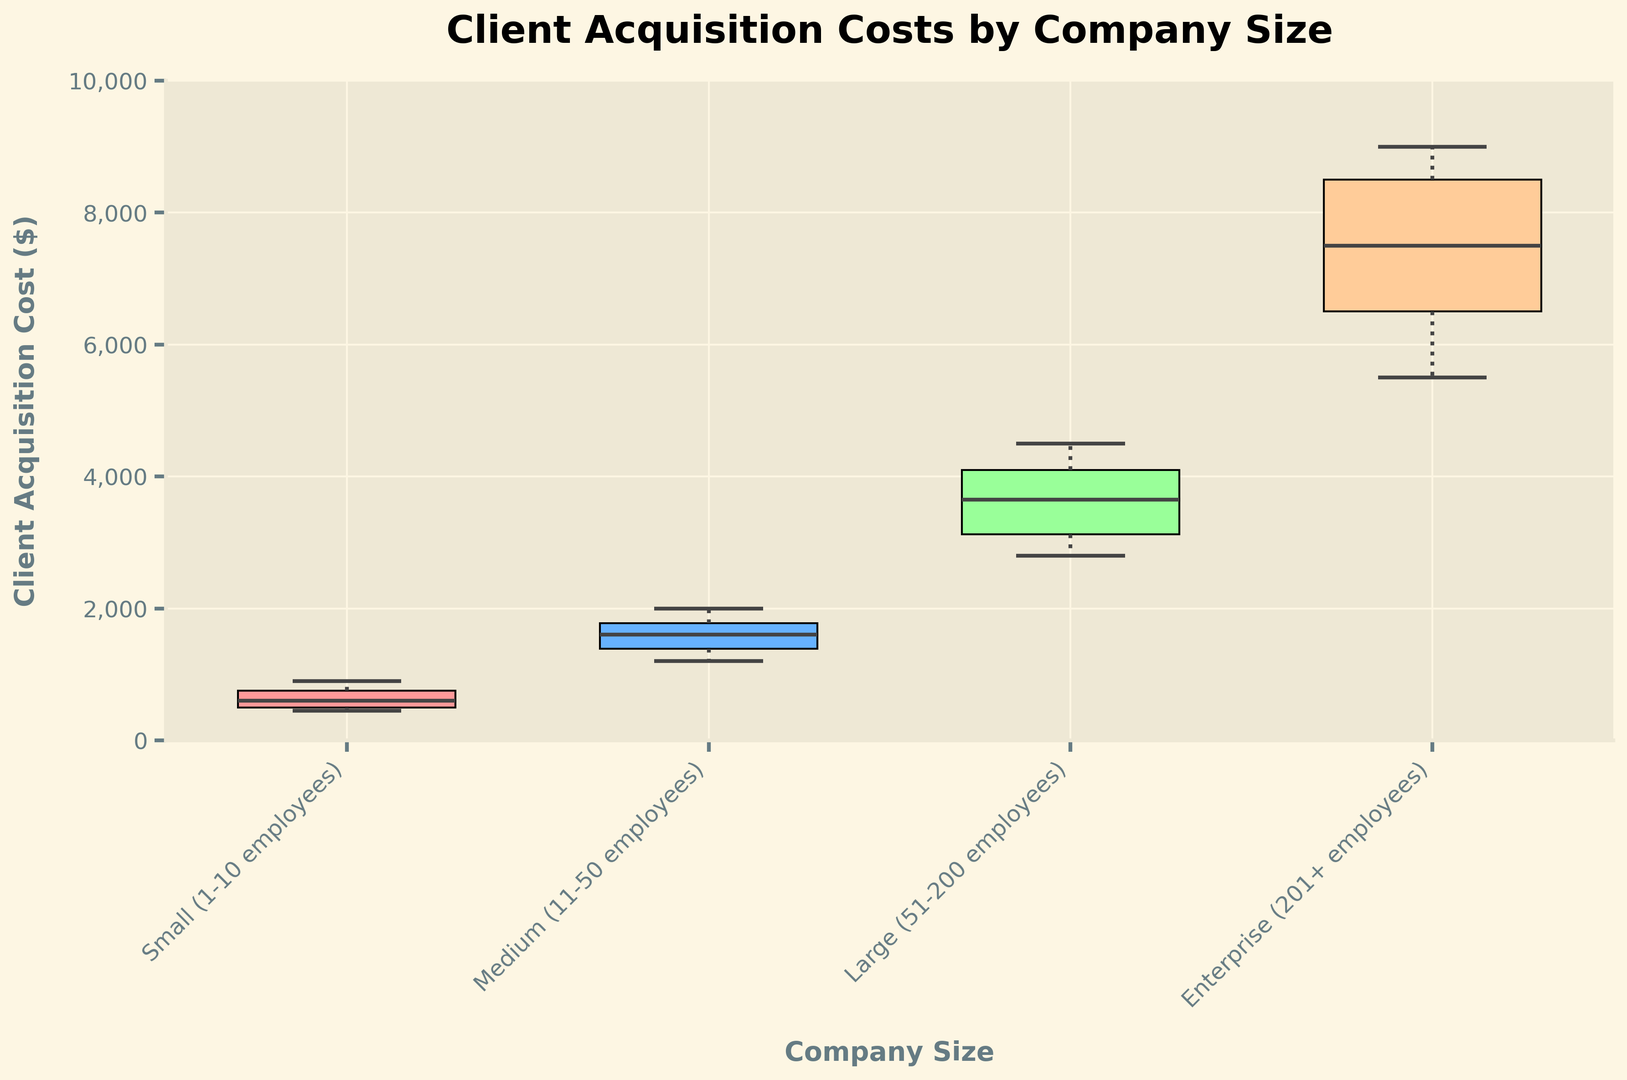What is the median Client Acquisition Cost for Small companies? To find the median, look at the middle value of the sorted data points for Small companies. The sorted data points are [450, 500, 600, 750, 900]. The median value is the middle one, which is 600.
Answer: 600 What is the range of Client Acquisition Costs for Medium companies? The range is calculated by subtracting the smallest value from the largest value in the data points for Medium companies. The costs are [1200, 1350, 1500, 1700, 1800, 2000], so the range is 2000 - 1200.
Answer: 800 Which company size category has the highest upper whisker in the box plot? The upper whisker represents the maximum data value excluding outliers. In the figure, the Enterprise company size has the highest upper whisker.
Answer: Enterprise For Large companies, what is the difference between the top and bottom quartile (interquartile range)? The interquartile range (IQR) is the difference between the third quartile (75th percentile) and the first quartile (25th percentile). For Large companies, the IQR is the distance between the top and bottom of the box. The 75th percentile is around 4000 and the 25th percentile is around 3000, so the IQR is 4000 - 3000.
Answer: 1000 Compare the median Client Acquisition Costs between Medium and Large companies. Which is greater? The medians are represented by the lines inside the boxes. The median for Medium companies is around 1700 and for Large companies, it's around 3500. The median for Large companies is greater than for Medium companies.
Answer: Large Which company size category shows the most variability in Client Acquisition Costs? Variability can be assessed by looking at the range and the spread of the box plot. The Enterprise category has the largest range and a widely spread box, indicating the most variability.
Answer: Enterprise What is the client acquisition cost at the maximum value for Small companies? The maximum value is represented by the top whisker for Small companies. Visually, this maximum value is around 900.
Answer: 900 How does the median Client Acquisition Cost for Enterprise compare to its third quartile? For Enterprise companies, the median is the line in the middle of the box, which is around 7500. The third quartile is the top edge of the box, which is around 8200. The median is less than the third quartile.
Answer: Less Does any company size category have outliers? Outliers are represented by points outside the whiskers. The box plot shows no points outside the whiskers for any of the company size categories, indicating no outliers.
Answer: No 